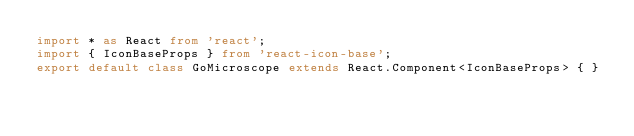Convert code to text. <code><loc_0><loc_0><loc_500><loc_500><_TypeScript_>import * as React from 'react';
import { IconBaseProps } from 'react-icon-base';
export default class GoMicroscope extends React.Component<IconBaseProps> { }
</code> 